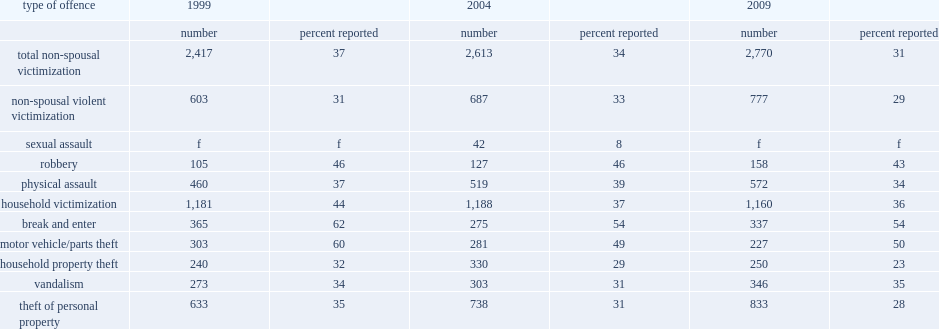Which type of offence had the highest rate of reporting to police in 2009? Break and enter. What was the percentage of thefts of motor vehicle/parts reported in 2009? 50.0. Which year had the fewest incidents of non-violent forms of victimization? 2009.0. What were the rate of reporting household crimes between 1999 and 2009? 44.0 36.0. 